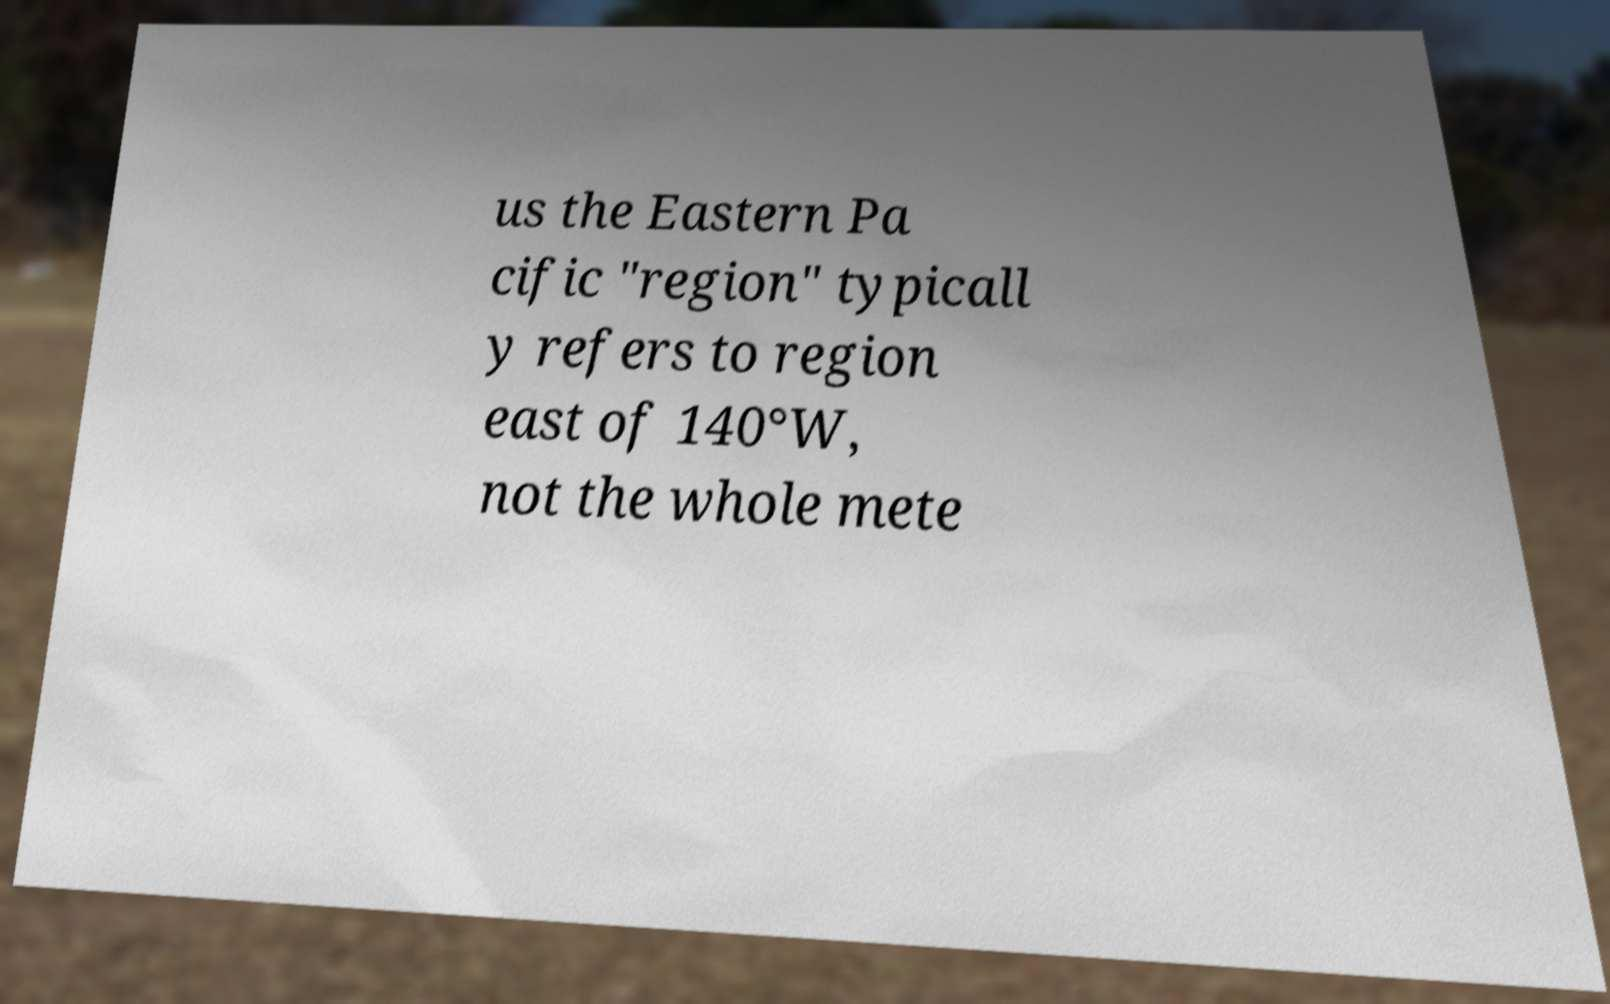Please read and relay the text visible in this image. What does it say? us the Eastern Pa cific "region" typicall y refers to region east of 140°W, not the whole mete 